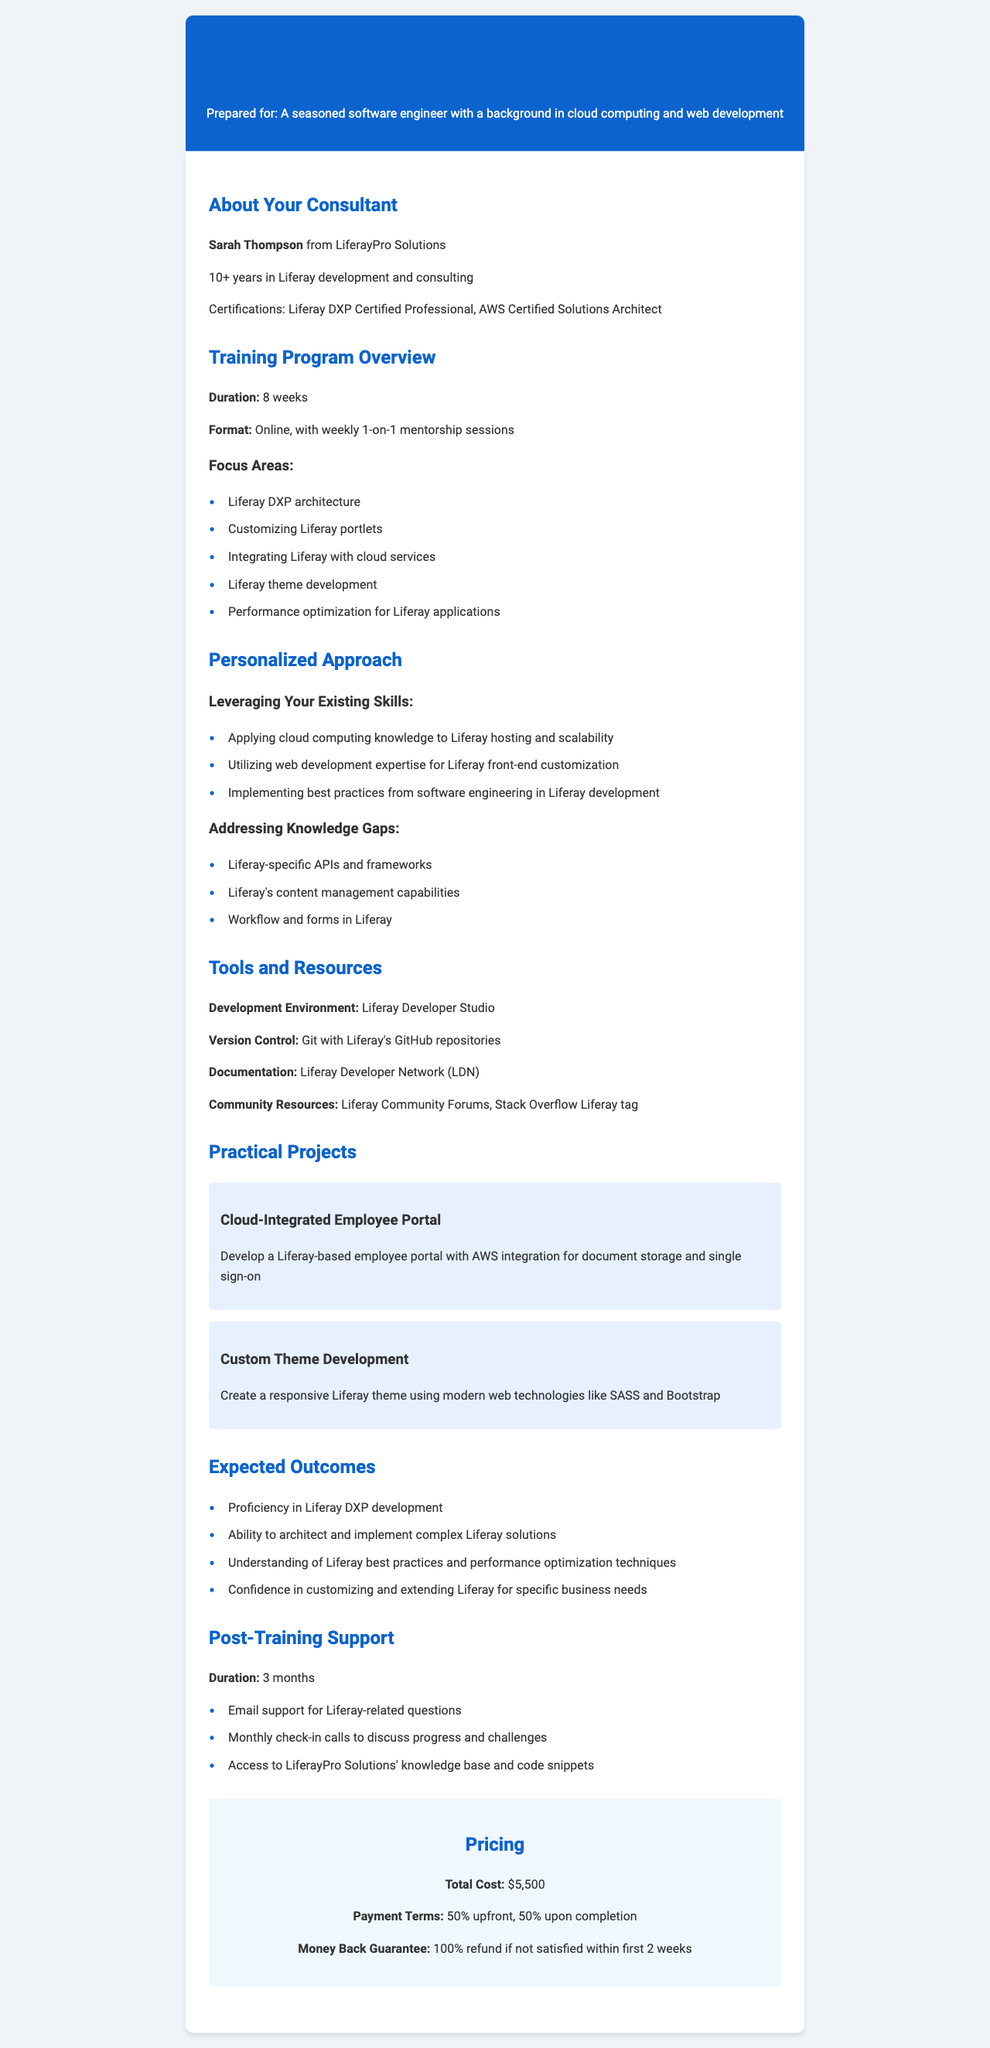What is the name of the consultant? The document mentions that the consultant's name is Sarah Thompson.
Answer: Sarah Thompson How many weeks is the training program? The training program's duration is explicitly stated as 8 weeks.
Answer: 8 weeks What is the total cost of the training program? The total cost is provided directly in the pricing section, which states it as $5,500.
Answer: $5,500 What is the main focus area of the training? One of the focus areas listed is "Customizing Liferay portlets."
Answer: Customizing Liferay portlets What type of support is offered after training? The post-training section indicates that email support for Liferay-related questions is provided.
Answer: Email support What are the payment terms for the training program? The document specifies the payment terms as 50% upfront, 50% upon completion.
Answer: 50% upfront, 50% upon completion How long is the post-training support duration? The document states that post-training support lasts for 3 months.
Answer: 3 months What is one of the practical projects included in the training? One of the practical projects listed is "Cloud-Integrated Employee Portal."
Answer: Cloud-Integrated Employee Portal What certification does the consultant have? The document mentions that the consultant is "Liferay DXP Certified Professional."
Answer: Liferay DXP Certified Professional 